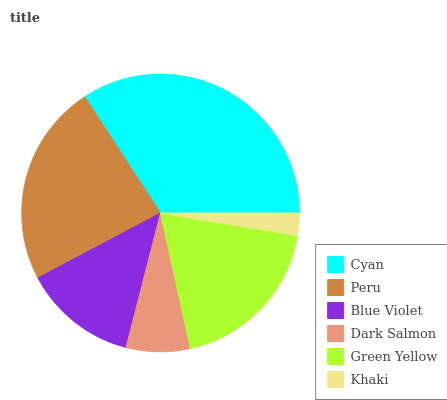Is Khaki the minimum?
Answer yes or no. Yes. Is Cyan the maximum?
Answer yes or no. Yes. Is Peru the minimum?
Answer yes or no. No. Is Peru the maximum?
Answer yes or no. No. Is Cyan greater than Peru?
Answer yes or no. Yes. Is Peru less than Cyan?
Answer yes or no. Yes. Is Peru greater than Cyan?
Answer yes or no. No. Is Cyan less than Peru?
Answer yes or no. No. Is Green Yellow the high median?
Answer yes or no. Yes. Is Blue Violet the low median?
Answer yes or no. Yes. Is Peru the high median?
Answer yes or no. No. Is Dark Salmon the low median?
Answer yes or no. No. 